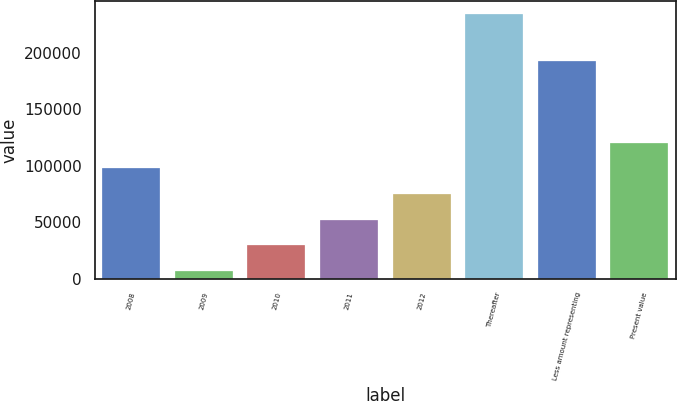Convert chart to OTSL. <chart><loc_0><loc_0><loc_500><loc_500><bar_chart><fcel>2008<fcel>2009<fcel>2010<fcel>2011<fcel>2012<fcel>Thereafter<fcel>Less amount representing<fcel>Present value<nl><fcel>97725.4<fcel>6905<fcel>29610.1<fcel>52315.2<fcel>75020.3<fcel>233956<fcel>192415<fcel>120430<nl></chart> 